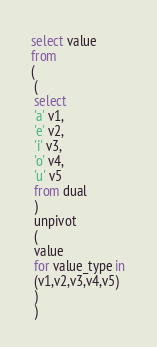<code> <loc_0><loc_0><loc_500><loc_500><_SQL_>select value
from
(
 (
 select
 'a' v1,
 'e' v2,
 'i' v3,
 'o' v4,
 'u' v5
 from dual
 )
 unpivot
 (
 value
 for value_type in
 (v1,v2,v3,v4,v5)
 )
 )

</code> 